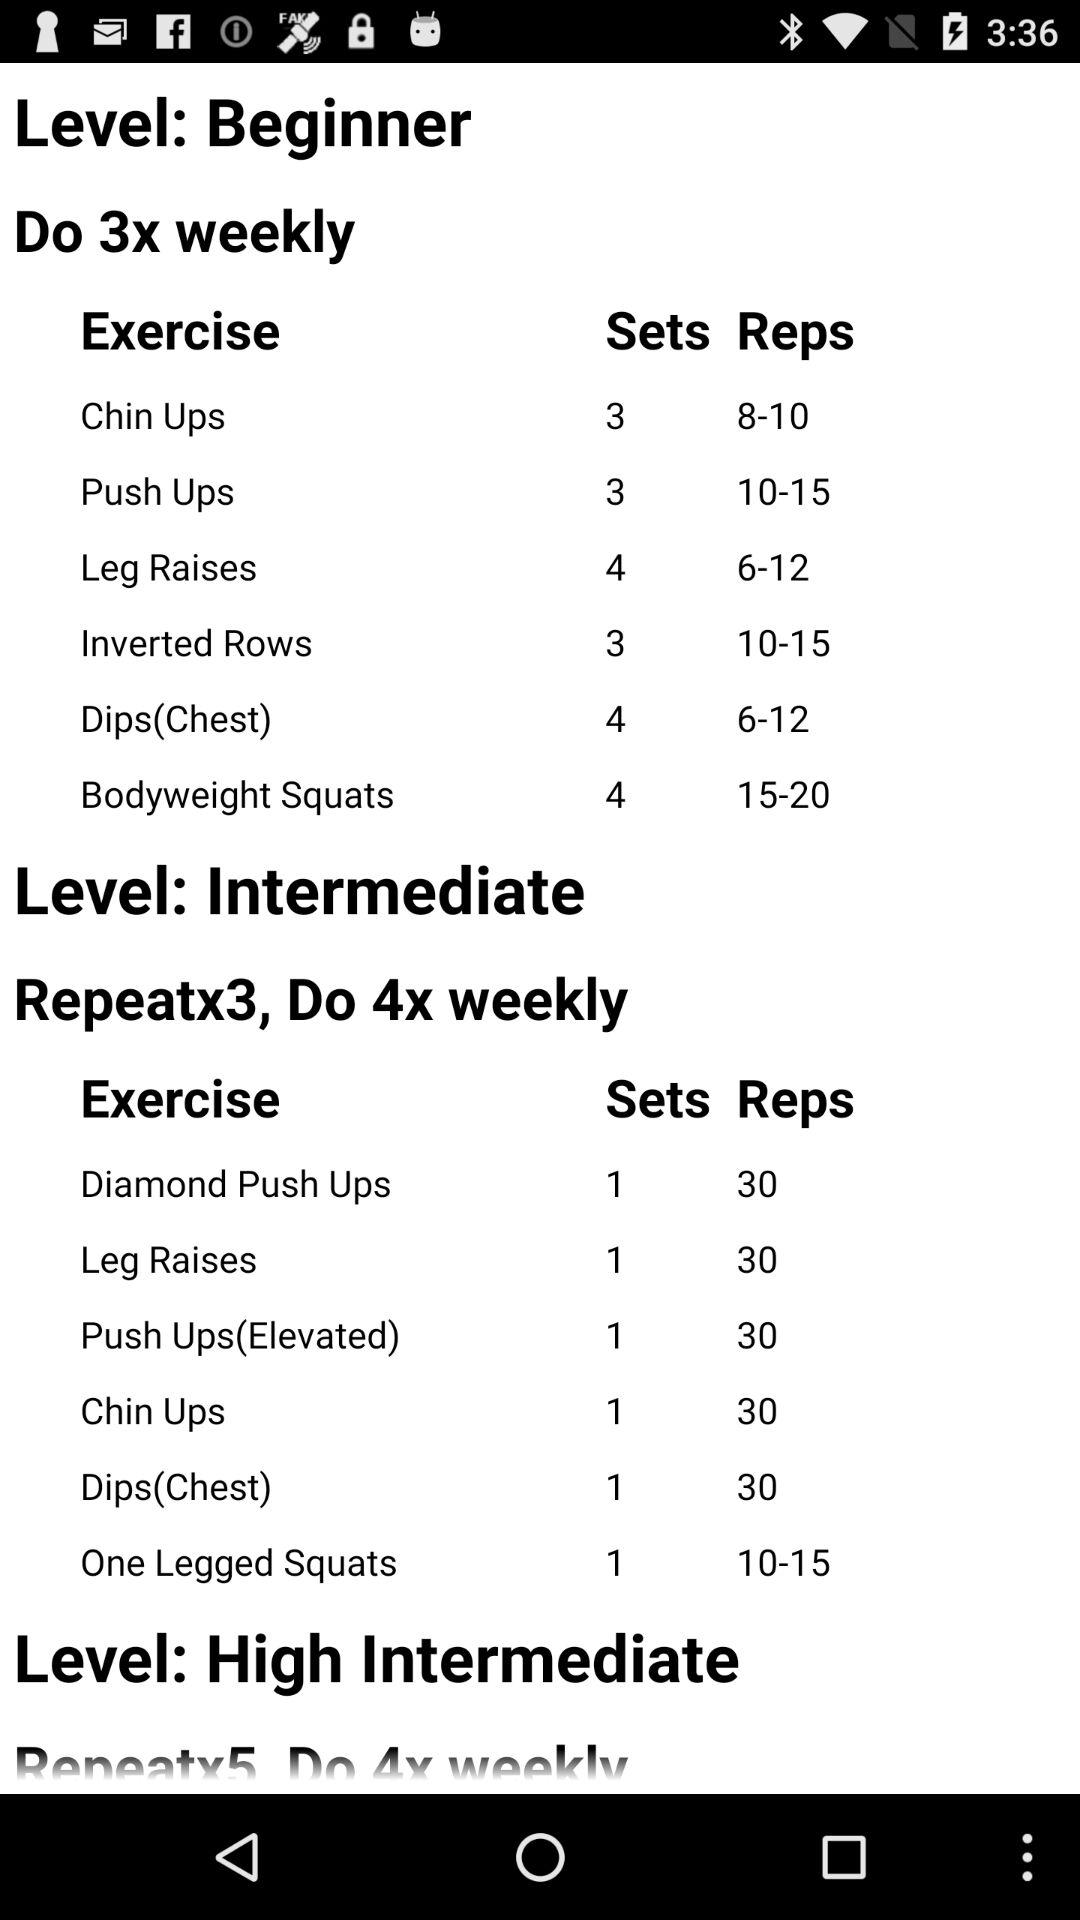How many reps of chin ups should we do at the intermediate level? You should do 30 reps of chin ups at the intermediate level. 